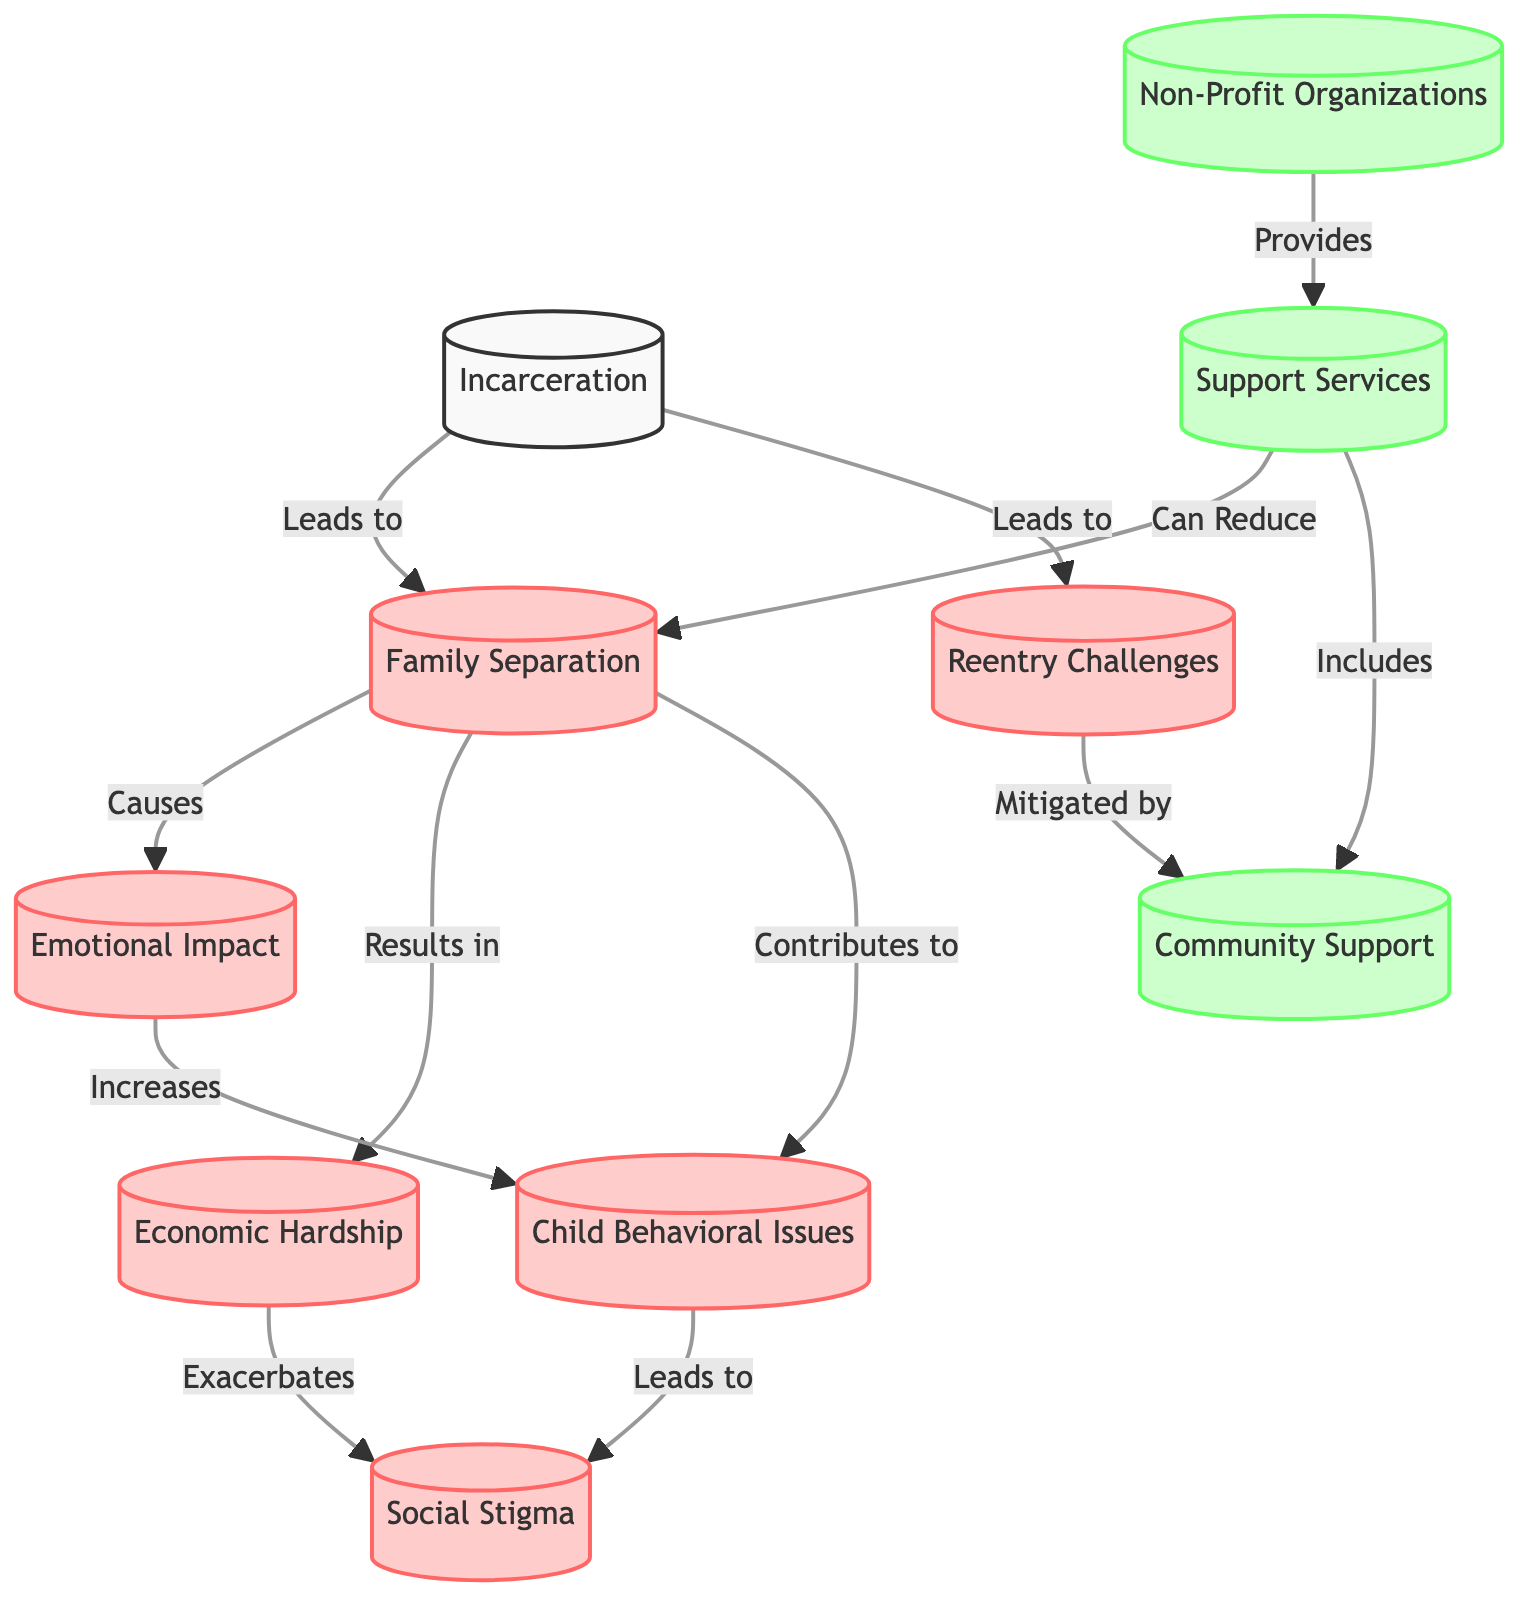What is the first node in the flowchart? The first node in the flowchart is "Incarceration." It is denoted as the starting point of the flowchart, which represents the primary issue being addressed.
Answer: Incarceration How many impact nodes are in the flowchart? There are six impact nodes in the flowchart: Family Separation, Emotional Impact, Economic Hardship, Child Behavioral Issues, Social Stigma, and Reentry Challenges. To count them, we look for nodes classified under the "impact" category.
Answer: 6 What does "Family Separation" lead to? "Family Separation" leads to three outcomes: "Emotional Impact," "Economic Hardship," and "Child Behavioral Issues." These relationships are indicated by directed arrows connecting "Family Separation" to three other nodes.
Answer: Emotional Impact, Economic Hardship, Child Behavioral Issues What is the relationship between "Economic Hardship" and "Social Stigma"? The relationship is that "Economic Hardship" exacerbates "Social Stigma." This is indicated by an arrow flowing from "Economic Hardship" to "Social Stigma," showing that increased economic strain contributes to greater social stigma.
Answer: Exacerbates Which node is mitigated by "Community Support"? The node that is mitigated by "Community Support" is "Reentry Challenges." This is shown by a directed arrow flowing from "Community Support" to "Reentry Challenges," indicating that community support can help alleviate these challenges.
Answer: Reentry Challenges How do support services interact with "Family Separation"? Support services can reduce "Family Separation." This is depicted in the flowchart where an arrow points from "Support Services" to "Family Separation," indicating that access to support can lessen the impact of family separation due to incarceration.
Answer: Can Reduce 